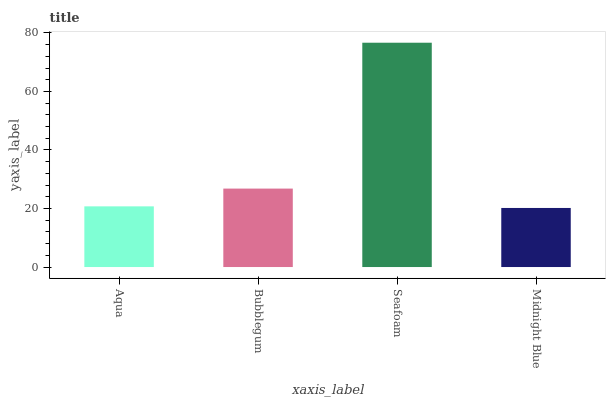Is Midnight Blue the minimum?
Answer yes or no. Yes. Is Seafoam the maximum?
Answer yes or no. Yes. Is Bubblegum the minimum?
Answer yes or no. No. Is Bubblegum the maximum?
Answer yes or no. No. Is Bubblegum greater than Aqua?
Answer yes or no. Yes. Is Aqua less than Bubblegum?
Answer yes or no. Yes. Is Aqua greater than Bubblegum?
Answer yes or no. No. Is Bubblegum less than Aqua?
Answer yes or no. No. Is Bubblegum the high median?
Answer yes or no. Yes. Is Aqua the low median?
Answer yes or no. Yes. Is Aqua the high median?
Answer yes or no. No. Is Midnight Blue the low median?
Answer yes or no. No. 